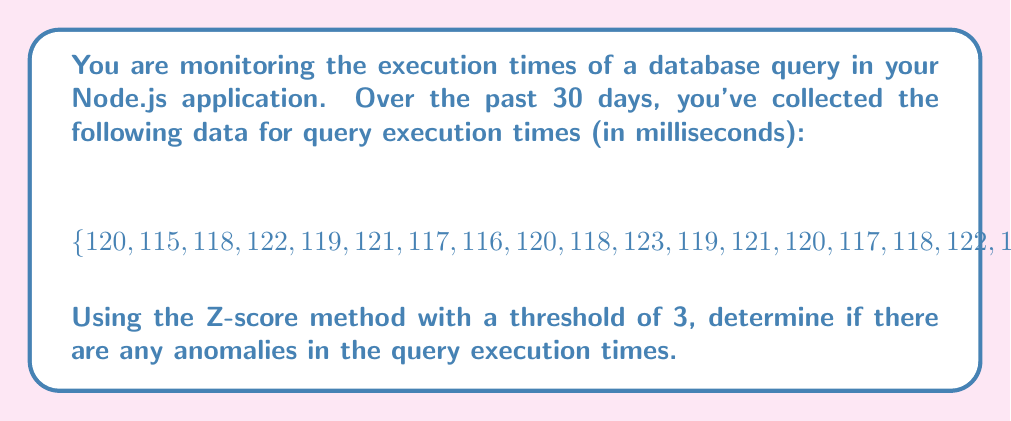Could you help me with this problem? To detect anomalies using the Z-score method, we need to follow these steps:

1. Calculate the mean ($\mu$) of the dataset:
   $$ \mu = \frac{\sum_{i=1}^{n} x_i}{n} $$
   Where $x_i$ are the individual values and $n$ is the number of values.

2. Calculate the standard deviation ($\sigma$) of the dataset:
   $$ \sigma = \sqrt{\frac{\sum_{i=1}^{n} (x_i - \mu)^2}{n}} $$

3. Calculate the Z-score for each data point:
   $$ Z = \frac{x - \mu}{\sigma} $$
   Where $x$ is the individual data point.

4. Identify anomalies: Any data point with a Z-score greater than 3 or less than -3 is considered an anomaly.

Let's perform these calculations:

1. Calculate the mean:
   $$ \mu = \frac{3604}{30} = 120.13 \text{ ms} $$

2. Calculate the standard deviation:
   $$ \sigma = \sqrt{\frac{\sum_{i=1}^{30} (x_i - 120.13)^2}{30}} \approx 6.18 \text{ ms} $$

3. Calculate Z-scores for each data point. Most Z-scores will be between -1 and 1, except for the last value (150 ms):
   $$ Z_{150} = \frac{150 - 120.13}{6.18} \approx 4.83 $$

4. Since the Z-score for 150 ms is greater than 3, it is considered an anomaly.
Answer: Yes, there is one anomaly in the query execution times: 150 ms, with a Z-score of approximately 4.83. 